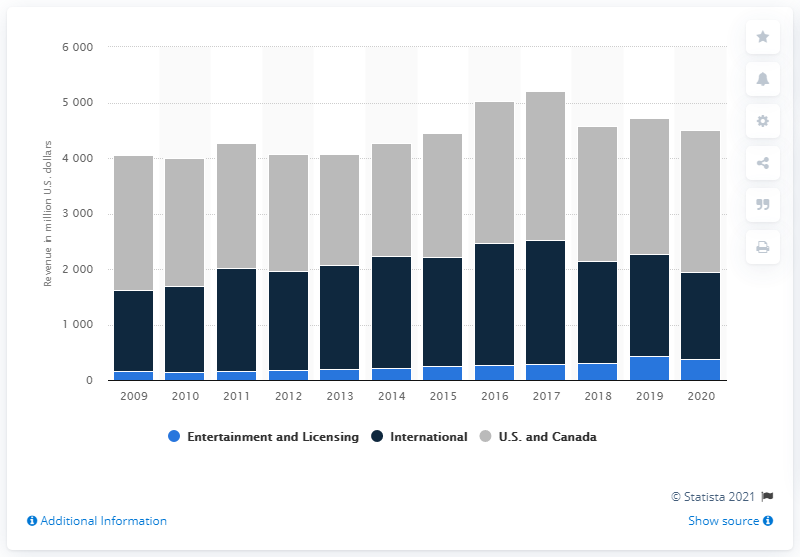Give some essential details in this illustration. Hasbro generated revenue of approximately 2556.1 million U.S. dollars in the United States and Canada in 2020. 